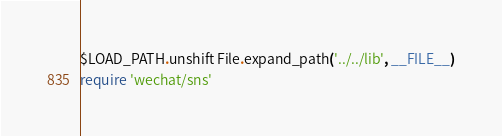Convert code to text. <code><loc_0><loc_0><loc_500><loc_500><_Ruby_>$LOAD_PATH.unshift File.expand_path('../../lib', __FILE__)
require 'wechat/sns'
</code> 